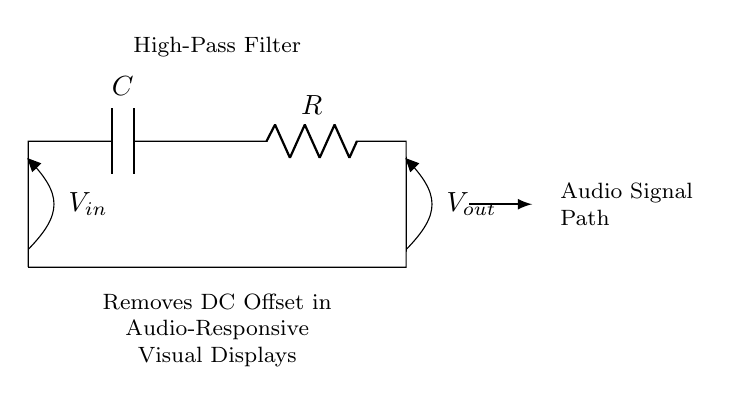What components make up this high-pass filter? The components are a capacitor (C) and a resistor (R), which are connected in series. The capacitor allows high-frequency signals to pass while blocking DC (low-frequency) signals, and the resistor determines the cutoff frequency.
Answer: capacitor and resistor What does the high-pass filter remove from the audio signal? The high-pass filter removes DC offset, which is the unwanted low-frequency content from the audio signal, allowing the AC components (higher frequencies) to be maintained for better audio responsiveness.
Answer: DC offset What is the role of the capacitor in this circuit? The capacitor blocks DC while allowing higher frequency signals to pass through. This means that any DC voltage present is effectively shorted to ground, while AC signals are allowed to continue through to the output.
Answer: blocks DC Which point represents the input voltage in the circuit? The input voltage is labelled as V_in and is at the top left of the circuit, where the audio signal is applied to the capacitor.
Answer: V_in How does the capacitor affect the cutoff frequency of this filter? The cutoff frequency is determined by the values of the capacitor and the resistor using the formula f_c = 1/(2πRC). As either R or C changes, the cutoff frequency will change, affecting how the circuit filters out lower frequencies.
Answer: changes with R and C What is the output voltage point labelled in this circuit? The output voltage point is labelled as V_out, which is the voltage across the resistor after the high-pass filtering effect has taken place, allowing only higher frequency signals to appear at this point.
Answer: V_out 